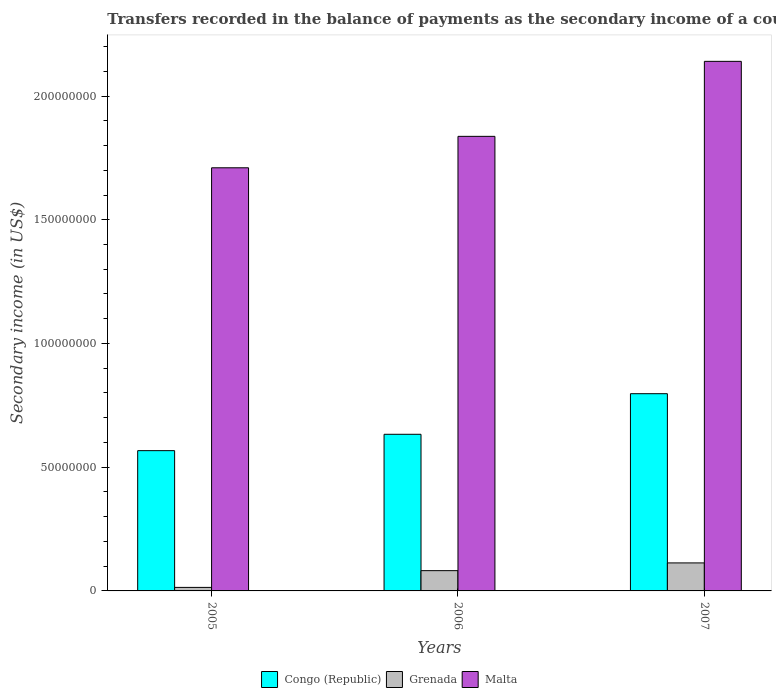How many groups of bars are there?
Provide a succinct answer. 3. Are the number of bars on each tick of the X-axis equal?
Provide a succinct answer. Yes. How many bars are there on the 3rd tick from the right?
Offer a very short reply. 3. In how many cases, is the number of bars for a given year not equal to the number of legend labels?
Your answer should be compact. 0. What is the secondary income of in Congo (Republic) in 2005?
Give a very brief answer. 5.67e+07. Across all years, what is the maximum secondary income of in Congo (Republic)?
Provide a short and direct response. 7.97e+07. Across all years, what is the minimum secondary income of in Grenada?
Offer a very short reply. 1.42e+06. In which year was the secondary income of in Congo (Republic) minimum?
Provide a short and direct response. 2005. What is the total secondary income of in Congo (Republic) in the graph?
Offer a very short reply. 2.00e+08. What is the difference between the secondary income of in Congo (Republic) in 2005 and that in 2007?
Offer a very short reply. -2.30e+07. What is the difference between the secondary income of in Malta in 2005 and the secondary income of in Congo (Republic) in 2006?
Your answer should be very brief. 1.08e+08. What is the average secondary income of in Grenada per year?
Your response must be concise. 6.98e+06. In the year 2006, what is the difference between the secondary income of in Grenada and secondary income of in Malta?
Give a very brief answer. -1.76e+08. In how many years, is the secondary income of in Malta greater than 200000000 US$?
Ensure brevity in your answer.  1. What is the ratio of the secondary income of in Grenada in 2005 to that in 2006?
Ensure brevity in your answer.  0.17. What is the difference between the highest and the second highest secondary income of in Congo (Republic)?
Ensure brevity in your answer.  1.64e+07. What is the difference between the highest and the lowest secondary income of in Malta?
Provide a short and direct response. 4.30e+07. In how many years, is the secondary income of in Congo (Republic) greater than the average secondary income of in Congo (Republic) taken over all years?
Provide a short and direct response. 1. Is the sum of the secondary income of in Congo (Republic) in 2006 and 2007 greater than the maximum secondary income of in Grenada across all years?
Offer a terse response. Yes. What does the 2nd bar from the left in 2006 represents?
Offer a very short reply. Grenada. What does the 3rd bar from the right in 2005 represents?
Provide a succinct answer. Congo (Republic). Is it the case that in every year, the sum of the secondary income of in Congo (Republic) and secondary income of in Malta is greater than the secondary income of in Grenada?
Your answer should be very brief. Yes. How many bars are there?
Keep it short and to the point. 9. Are all the bars in the graph horizontal?
Ensure brevity in your answer.  No. Are the values on the major ticks of Y-axis written in scientific E-notation?
Ensure brevity in your answer.  No. Does the graph contain grids?
Give a very brief answer. No. How many legend labels are there?
Your answer should be compact. 3. What is the title of the graph?
Ensure brevity in your answer.  Transfers recorded in the balance of payments as the secondary income of a country. Does "Zambia" appear as one of the legend labels in the graph?
Make the answer very short. No. What is the label or title of the X-axis?
Ensure brevity in your answer.  Years. What is the label or title of the Y-axis?
Make the answer very short. Secondary income (in US$). What is the Secondary income (in US$) in Congo (Republic) in 2005?
Ensure brevity in your answer.  5.67e+07. What is the Secondary income (in US$) in Grenada in 2005?
Your response must be concise. 1.42e+06. What is the Secondary income (in US$) in Malta in 2005?
Give a very brief answer. 1.71e+08. What is the Secondary income (in US$) of Congo (Republic) in 2006?
Give a very brief answer. 6.33e+07. What is the Secondary income (in US$) of Grenada in 2006?
Provide a short and direct response. 8.19e+06. What is the Secondary income (in US$) in Malta in 2006?
Provide a succinct answer. 1.84e+08. What is the Secondary income (in US$) in Congo (Republic) in 2007?
Keep it short and to the point. 7.97e+07. What is the Secondary income (in US$) of Grenada in 2007?
Your answer should be compact. 1.13e+07. What is the Secondary income (in US$) in Malta in 2007?
Make the answer very short. 2.14e+08. Across all years, what is the maximum Secondary income (in US$) in Congo (Republic)?
Your answer should be very brief. 7.97e+07. Across all years, what is the maximum Secondary income (in US$) of Grenada?
Your answer should be very brief. 1.13e+07. Across all years, what is the maximum Secondary income (in US$) of Malta?
Your answer should be compact. 2.14e+08. Across all years, what is the minimum Secondary income (in US$) of Congo (Republic)?
Give a very brief answer. 5.67e+07. Across all years, what is the minimum Secondary income (in US$) in Grenada?
Provide a short and direct response. 1.42e+06. Across all years, what is the minimum Secondary income (in US$) of Malta?
Your answer should be very brief. 1.71e+08. What is the total Secondary income (in US$) of Congo (Republic) in the graph?
Your response must be concise. 2.00e+08. What is the total Secondary income (in US$) of Grenada in the graph?
Your answer should be very brief. 2.09e+07. What is the total Secondary income (in US$) of Malta in the graph?
Your answer should be compact. 5.69e+08. What is the difference between the Secondary income (in US$) in Congo (Republic) in 2005 and that in 2006?
Provide a succinct answer. -6.62e+06. What is the difference between the Secondary income (in US$) in Grenada in 2005 and that in 2006?
Your response must be concise. -6.77e+06. What is the difference between the Secondary income (in US$) of Malta in 2005 and that in 2006?
Give a very brief answer. -1.27e+07. What is the difference between the Secondary income (in US$) of Congo (Republic) in 2005 and that in 2007?
Keep it short and to the point. -2.30e+07. What is the difference between the Secondary income (in US$) in Grenada in 2005 and that in 2007?
Ensure brevity in your answer.  -9.89e+06. What is the difference between the Secondary income (in US$) of Malta in 2005 and that in 2007?
Offer a very short reply. -4.30e+07. What is the difference between the Secondary income (in US$) in Congo (Republic) in 2006 and that in 2007?
Your answer should be very brief. -1.64e+07. What is the difference between the Secondary income (in US$) in Grenada in 2006 and that in 2007?
Provide a short and direct response. -3.13e+06. What is the difference between the Secondary income (in US$) in Malta in 2006 and that in 2007?
Give a very brief answer. -3.03e+07. What is the difference between the Secondary income (in US$) in Congo (Republic) in 2005 and the Secondary income (in US$) in Grenada in 2006?
Ensure brevity in your answer.  4.85e+07. What is the difference between the Secondary income (in US$) in Congo (Republic) in 2005 and the Secondary income (in US$) in Malta in 2006?
Provide a short and direct response. -1.27e+08. What is the difference between the Secondary income (in US$) of Grenada in 2005 and the Secondary income (in US$) of Malta in 2006?
Keep it short and to the point. -1.82e+08. What is the difference between the Secondary income (in US$) of Congo (Republic) in 2005 and the Secondary income (in US$) of Grenada in 2007?
Offer a very short reply. 4.54e+07. What is the difference between the Secondary income (in US$) in Congo (Republic) in 2005 and the Secondary income (in US$) in Malta in 2007?
Make the answer very short. -1.57e+08. What is the difference between the Secondary income (in US$) in Grenada in 2005 and the Secondary income (in US$) in Malta in 2007?
Your answer should be compact. -2.13e+08. What is the difference between the Secondary income (in US$) in Congo (Republic) in 2006 and the Secondary income (in US$) in Grenada in 2007?
Offer a terse response. 5.20e+07. What is the difference between the Secondary income (in US$) of Congo (Republic) in 2006 and the Secondary income (in US$) of Malta in 2007?
Give a very brief answer. -1.51e+08. What is the difference between the Secondary income (in US$) of Grenada in 2006 and the Secondary income (in US$) of Malta in 2007?
Your response must be concise. -2.06e+08. What is the average Secondary income (in US$) of Congo (Republic) per year?
Offer a very short reply. 6.66e+07. What is the average Secondary income (in US$) of Grenada per year?
Make the answer very short. 6.98e+06. What is the average Secondary income (in US$) in Malta per year?
Give a very brief answer. 1.90e+08. In the year 2005, what is the difference between the Secondary income (in US$) in Congo (Republic) and Secondary income (in US$) in Grenada?
Provide a short and direct response. 5.53e+07. In the year 2005, what is the difference between the Secondary income (in US$) of Congo (Republic) and Secondary income (in US$) of Malta?
Provide a short and direct response. -1.14e+08. In the year 2005, what is the difference between the Secondary income (in US$) of Grenada and Secondary income (in US$) of Malta?
Give a very brief answer. -1.70e+08. In the year 2006, what is the difference between the Secondary income (in US$) of Congo (Republic) and Secondary income (in US$) of Grenada?
Give a very brief answer. 5.51e+07. In the year 2006, what is the difference between the Secondary income (in US$) in Congo (Republic) and Secondary income (in US$) in Malta?
Provide a succinct answer. -1.20e+08. In the year 2006, what is the difference between the Secondary income (in US$) of Grenada and Secondary income (in US$) of Malta?
Provide a succinct answer. -1.76e+08. In the year 2007, what is the difference between the Secondary income (in US$) of Congo (Republic) and Secondary income (in US$) of Grenada?
Your response must be concise. 6.84e+07. In the year 2007, what is the difference between the Secondary income (in US$) in Congo (Republic) and Secondary income (in US$) in Malta?
Keep it short and to the point. -1.34e+08. In the year 2007, what is the difference between the Secondary income (in US$) of Grenada and Secondary income (in US$) of Malta?
Your response must be concise. -2.03e+08. What is the ratio of the Secondary income (in US$) in Congo (Republic) in 2005 to that in 2006?
Your response must be concise. 0.9. What is the ratio of the Secondary income (in US$) of Grenada in 2005 to that in 2006?
Provide a short and direct response. 0.17. What is the ratio of the Secondary income (in US$) in Malta in 2005 to that in 2006?
Provide a short and direct response. 0.93. What is the ratio of the Secondary income (in US$) in Congo (Republic) in 2005 to that in 2007?
Provide a short and direct response. 0.71. What is the ratio of the Secondary income (in US$) in Grenada in 2005 to that in 2007?
Provide a succinct answer. 0.13. What is the ratio of the Secondary income (in US$) in Malta in 2005 to that in 2007?
Your answer should be compact. 0.8. What is the ratio of the Secondary income (in US$) of Congo (Republic) in 2006 to that in 2007?
Keep it short and to the point. 0.79. What is the ratio of the Secondary income (in US$) of Grenada in 2006 to that in 2007?
Offer a very short reply. 0.72. What is the ratio of the Secondary income (in US$) in Malta in 2006 to that in 2007?
Your response must be concise. 0.86. What is the difference between the highest and the second highest Secondary income (in US$) in Congo (Republic)?
Offer a terse response. 1.64e+07. What is the difference between the highest and the second highest Secondary income (in US$) in Grenada?
Ensure brevity in your answer.  3.13e+06. What is the difference between the highest and the second highest Secondary income (in US$) in Malta?
Your answer should be very brief. 3.03e+07. What is the difference between the highest and the lowest Secondary income (in US$) in Congo (Republic)?
Offer a very short reply. 2.30e+07. What is the difference between the highest and the lowest Secondary income (in US$) of Grenada?
Provide a succinct answer. 9.89e+06. What is the difference between the highest and the lowest Secondary income (in US$) in Malta?
Keep it short and to the point. 4.30e+07. 